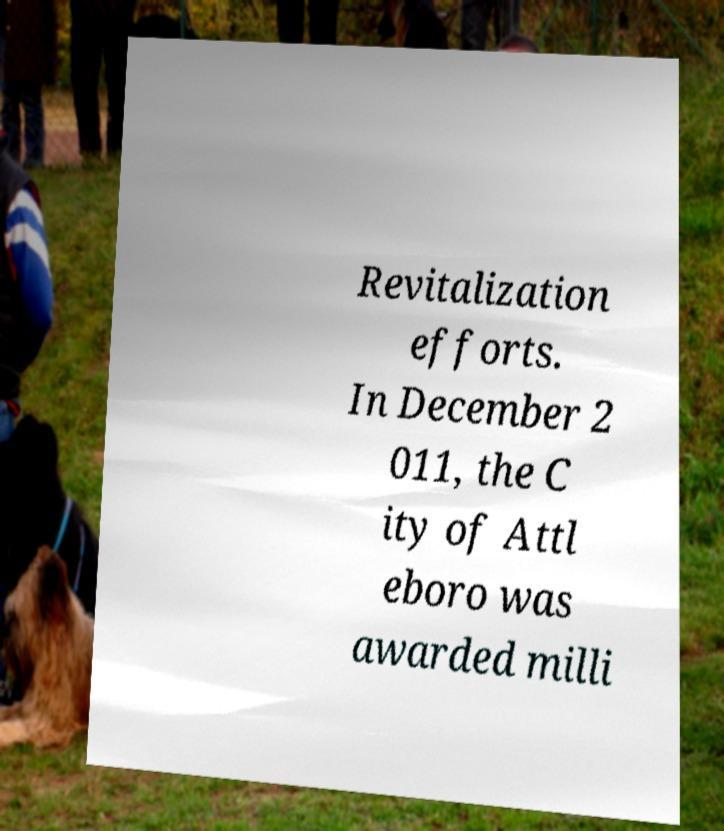For documentation purposes, I need the text within this image transcribed. Could you provide that? Revitalization efforts. In December 2 011, the C ity of Attl eboro was awarded milli 